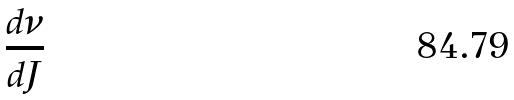Convert formula to latex. <formula><loc_0><loc_0><loc_500><loc_500>\frac { d \nu } { d J }</formula> 